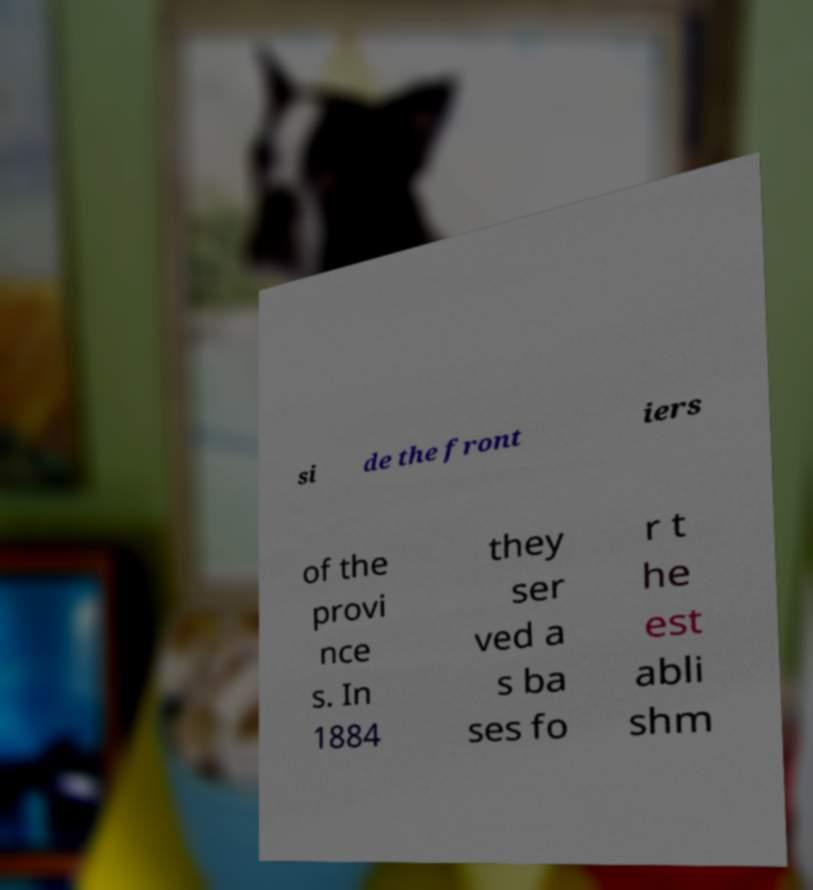Please identify and transcribe the text found in this image. si de the front iers of the provi nce s. In 1884 they ser ved a s ba ses fo r t he est abli shm 